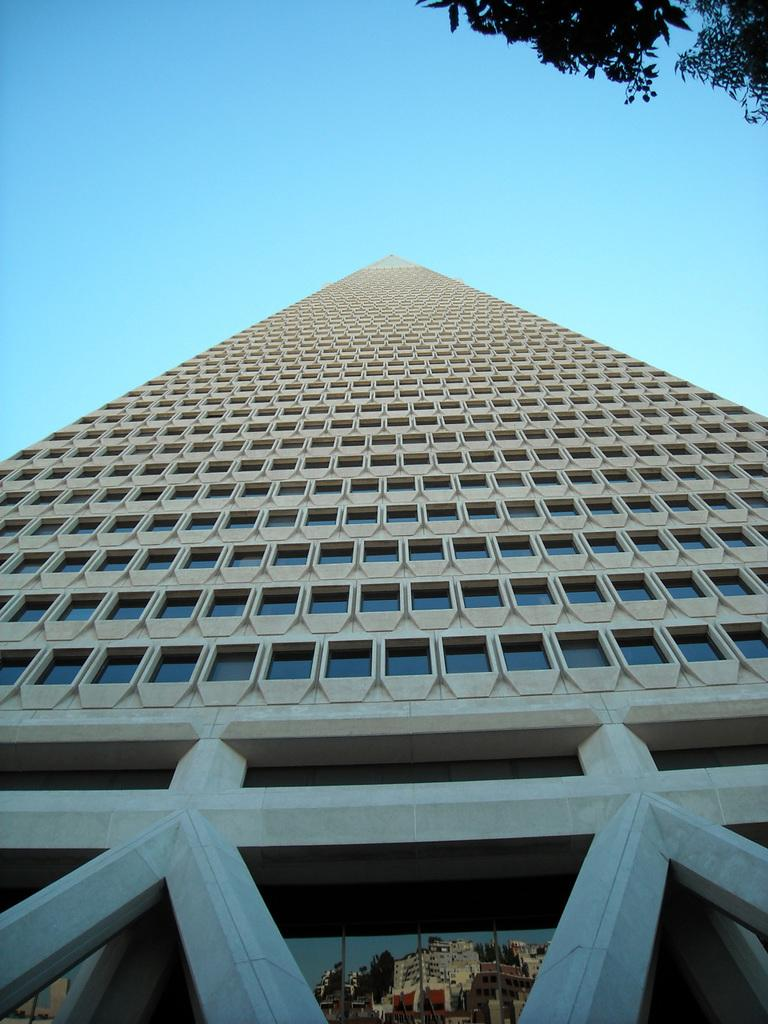What type of structure is present in the image? There is a building in the image. What feature of the building is mentioned in the facts? The building has glass. What can be observed about the glass in the image? The glass reflects other buildings and trees. What is visible in the background of the image? There is sky visible in the background of the image. How many kittens are sitting on the quill in the image? There are no kittens or quills present in the image. 